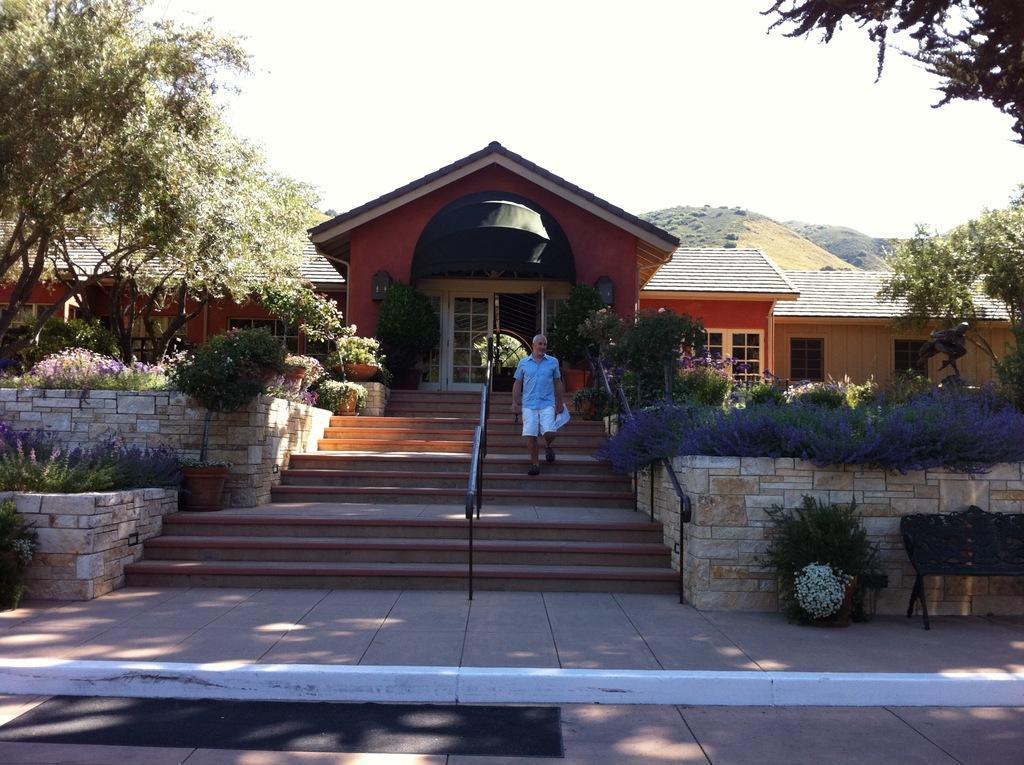Describe this image in one or two sentences. The man in the blue shirt is standing on the staircase. He is holding something in his hands. Beside him, we see the stair railing. On either side of the picture, we see flower pots, plants and shrubs. On either side of the picture, there are trees and we even see the wall.. On the right side, we see a bench in black color. In the background, we see a building with a grey color roof. There are hills in the background. At the top, we see the sky. At the bottom, we see the footpath. 